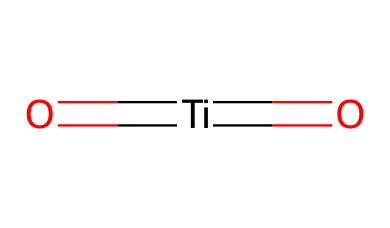What is the central atom in this structure? The structure shows a titanium atom (Ti) in the center of the formula, indicated by its symbol.
Answer: titanium How many oxygen atoms are present in this chemical? The structure includes two oxygen atoms, each represented by the letter 'O' in the formula.
Answer: two What type of compound is represented by this SMILES? The presence of titanium and oxygen indicates that this is a metal oxide, as it features a metal (titanium) bonded to oxygen atoms.
Answer: metal oxide What oxidation state does titanium exhibit here? In the structure, titanium is bonded to oxygen with a double bond (indicated by '=') suggesting it is in the +4 oxidation state, a common state for titanium in metal oxides.
Answer: +4 What is the significance of the double bond in this structure? The double bond between titanium and oxygen signifies a strong bond characteristic of titanium's ability to form stable compounds with oxygen in metal oxides, which also contributes to the pigmentation properties important in makeup.
Answer: strong bond Does this compound have any ionic characteristics? Yes, the presence of metal (Ti) and non-metal (O) typically indicates ionic characteristics, as metals tend to lose electrons and non-metals to gain them, thus forming ionic compounds.
Answer: ionic characteristics 